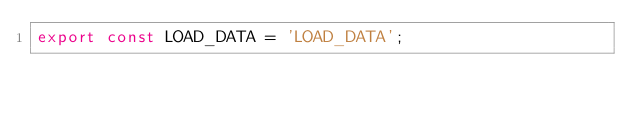<code> <loc_0><loc_0><loc_500><loc_500><_JavaScript_>export const LOAD_DATA = 'LOAD_DATA';
</code> 